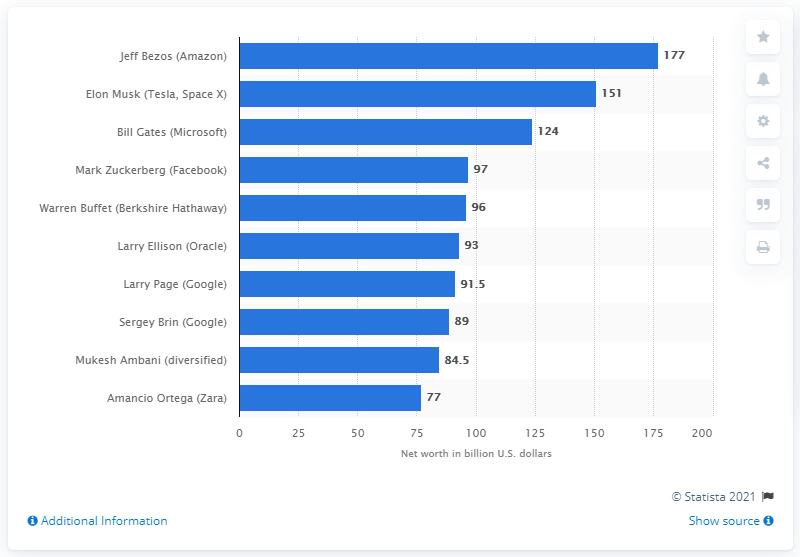Specify some key components in this picture. Mark Zuckerberg's estimated net worth was approximately 97 billion dollars. 